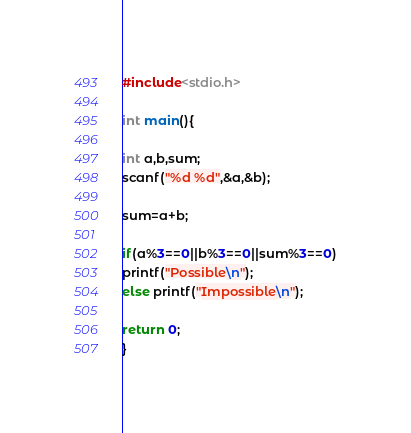Convert code to text. <code><loc_0><loc_0><loc_500><loc_500><_C_>#include<stdio.h>

int main(){

int a,b,sum;
scanf("%d %d",&a,&b);

sum=a+b;

if(a%3==0||b%3==0||sum%3==0)
printf("Possible\n"); 
else printf("Impossible\n"); 

return 0;
}</code> 